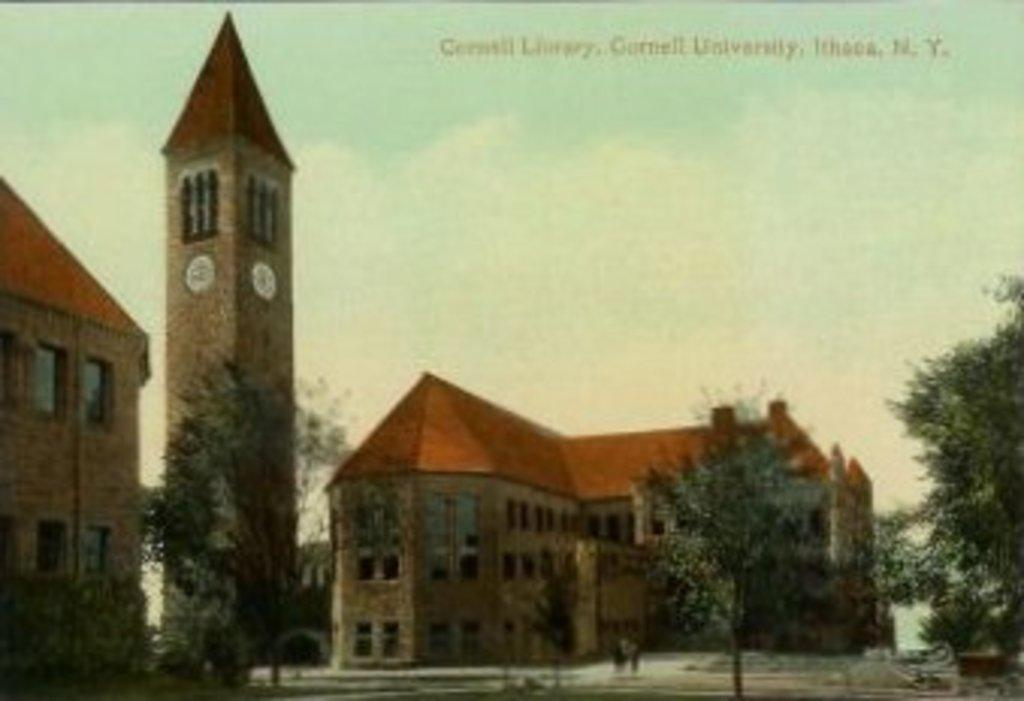What type of structures can be seen in the image? There are buildings in the image. What other natural elements are present in the image? There are trees in the image. What specific architectural feature is visible in the image? There is a clock tower in the image. What can be seen through the windows in the image? Windows are visible in the image, but it is not possible to see through them from this image. How many people are present on the road in the image? There are two persons on the road in the image. What is visible in the background of the image? The sky and a text are visible in the background of the image. Can you describe the nature of the image? The image appears to be an edited photo. What type of store can be seen in the image? There is no store visible in the image. What type of suit is the monkey wearing in the image? There is no monkey present in the image, and therefore no suit can be observed. 